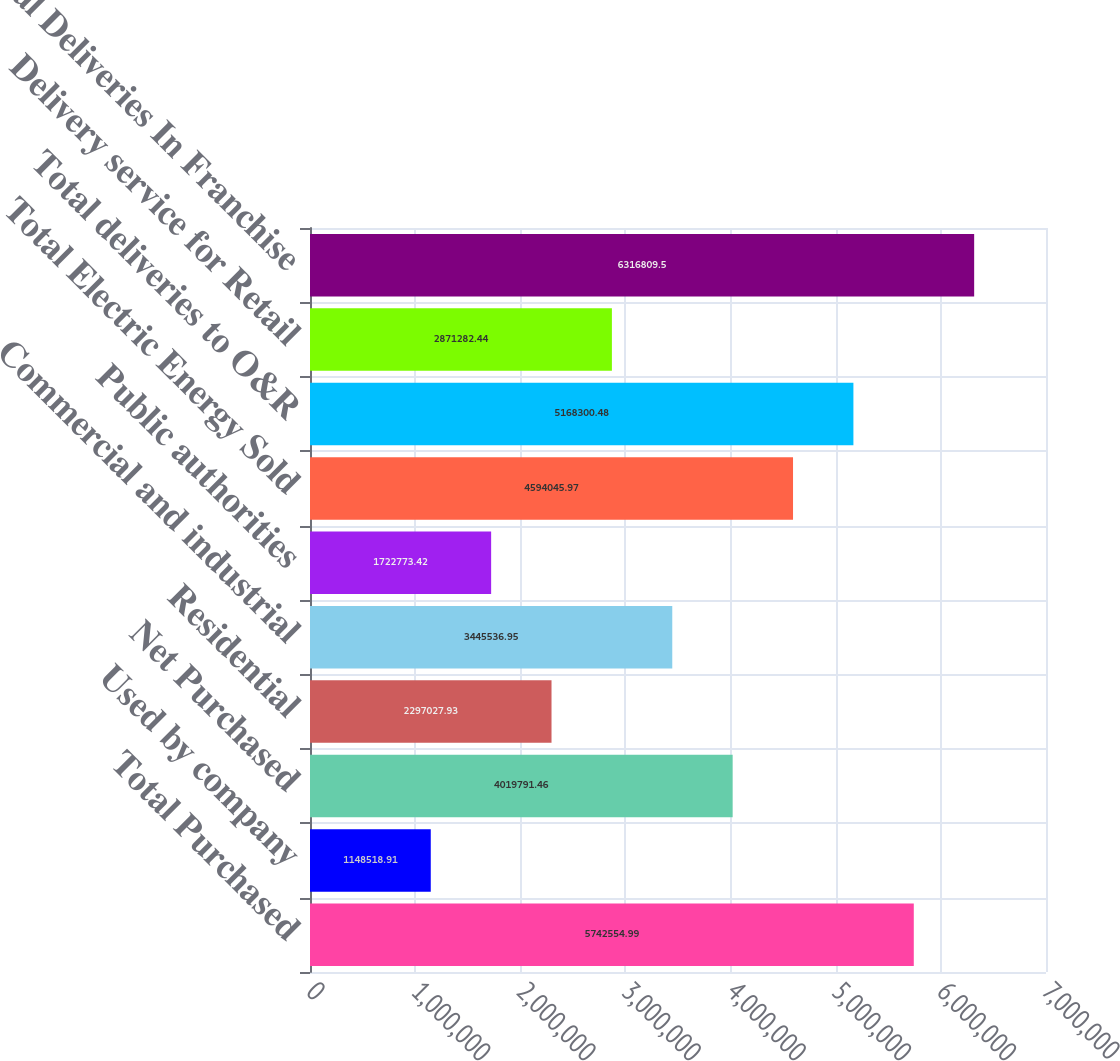Convert chart to OTSL. <chart><loc_0><loc_0><loc_500><loc_500><bar_chart><fcel>Total Purchased<fcel>Used by company<fcel>Net Purchased<fcel>Residential<fcel>Commercial and industrial<fcel>Public authorities<fcel>Total Electric Energy Sold<fcel>Total deliveries to O&R<fcel>Delivery service for Retail<fcel>Total Deliveries In Franchise<nl><fcel>5.74255e+06<fcel>1.14852e+06<fcel>4.01979e+06<fcel>2.29703e+06<fcel>3.44554e+06<fcel>1.72277e+06<fcel>4.59405e+06<fcel>5.1683e+06<fcel>2.87128e+06<fcel>6.31681e+06<nl></chart> 